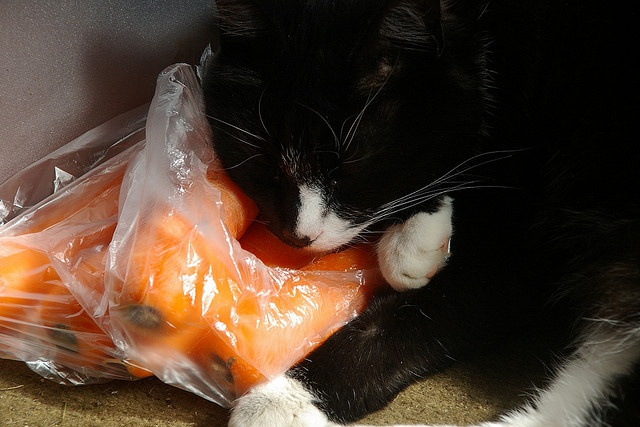Describe the objects in this image and their specific colors. I can see cat in black, gray, darkgray, and ivory tones, carrot in gray, tan, orange, and brown tones, carrot in gray, orange, tan, and maroon tones, carrot in gray, brown, and tan tones, and carrot in gray, orange, tan, maroon, and red tones in this image. 